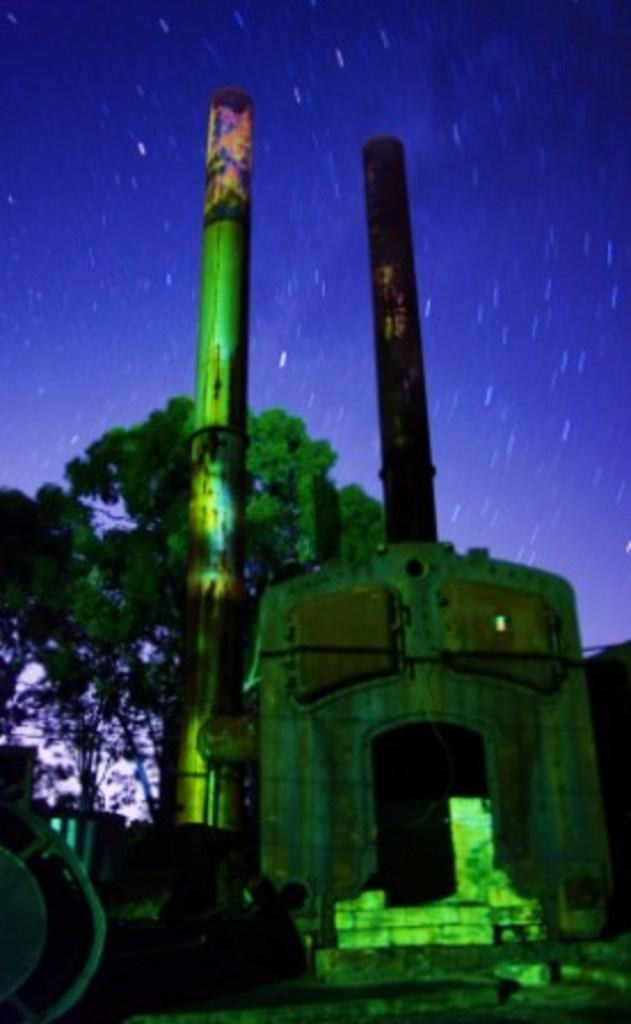What can be said about the overall appearance of the image? The image is colorful. What can be seen in the background of the image? There is a sky visible in the background of the image. What type of natural elements are present in the image? There are trees in the image. What man-made structures can be seen in the image? There are poles in the image. What else is present in the image besides the sky, trees, and poles? There are objects in the image. What type of shade does the wing provide in the image? There is no wing present in the image, so it cannot provide any shade. 